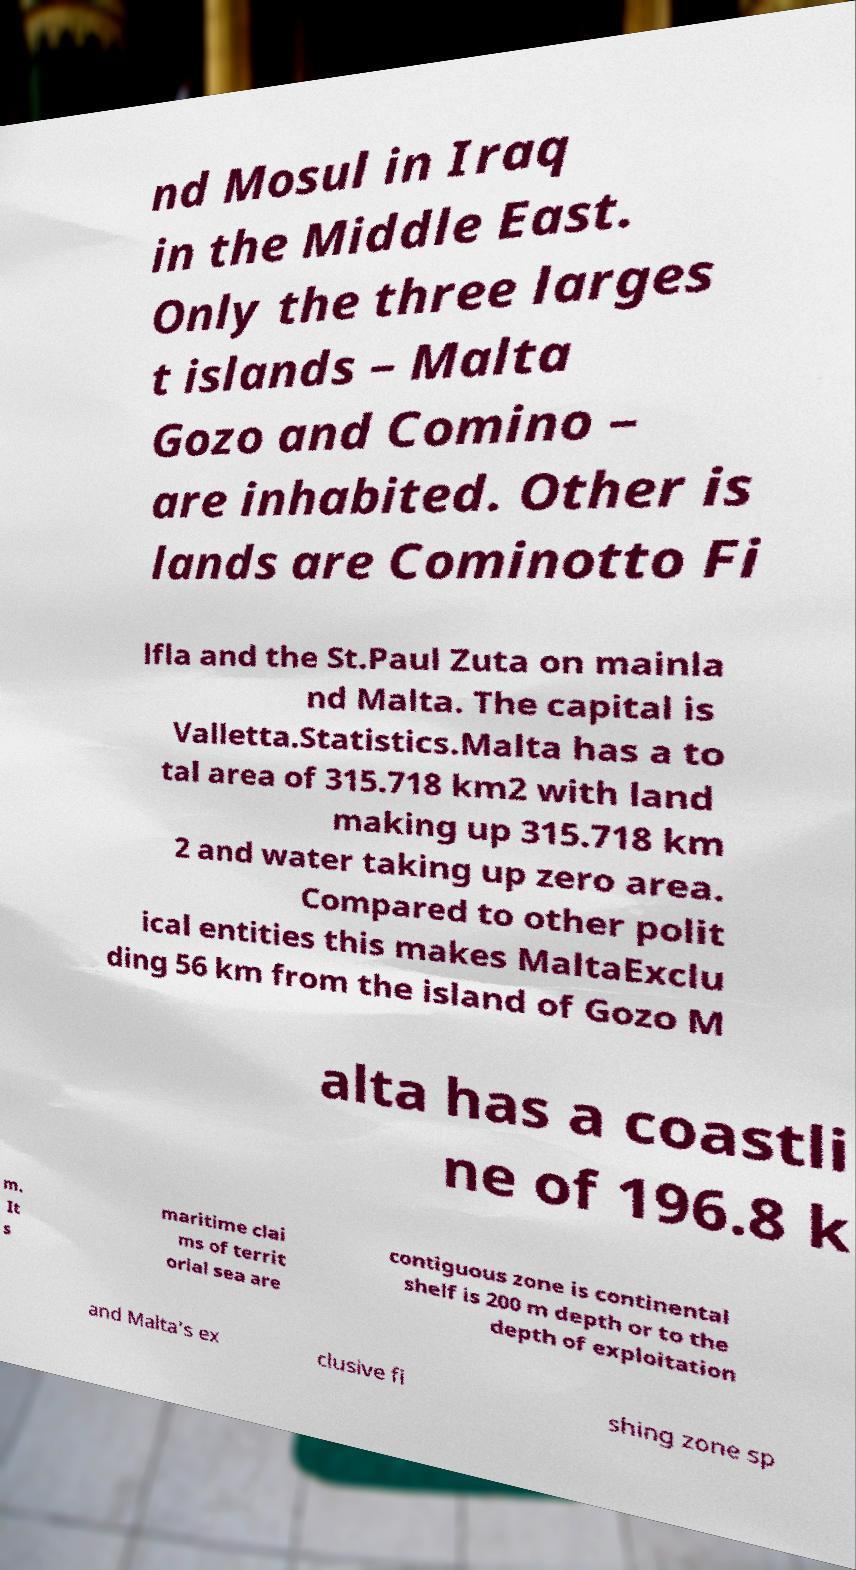Please identify and transcribe the text found in this image. nd Mosul in Iraq in the Middle East. Only the three larges t islands – Malta Gozo and Comino – are inhabited. Other is lands are Cominotto Fi lfla and the St.Paul Zuta on mainla nd Malta. The capital is Valletta.Statistics.Malta has a to tal area of 315.718 km2 with land making up 315.718 km 2 and water taking up zero area. Compared to other polit ical entities this makes MaltaExclu ding 56 km from the island of Gozo M alta has a coastli ne of 196.8 k m. It s maritime clai ms of territ orial sea are contiguous zone is continental shelf is 200 m depth or to the depth of exploitation and Malta's ex clusive fi shing zone sp 